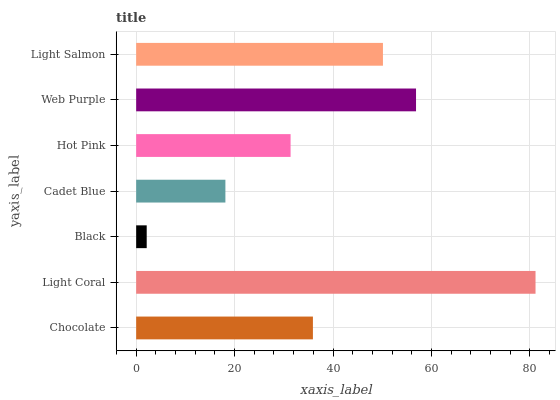Is Black the minimum?
Answer yes or no. Yes. Is Light Coral the maximum?
Answer yes or no. Yes. Is Light Coral the minimum?
Answer yes or no. No. Is Black the maximum?
Answer yes or no. No. Is Light Coral greater than Black?
Answer yes or no. Yes. Is Black less than Light Coral?
Answer yes or no. Yes. Is Black greater than Light Coral?
Answer yes or no. No. Is Light Coral less than Black?
Answer yes or no. No. Is Chocolate the high median?
Answer yes or no. Yes. Is Chocolate the low median?
Answer yes or no. Yes. Is Cadet Blue the high median?
Answer yes or no. No. Is Light Salmon the low median?
Answer yes or no. No. 